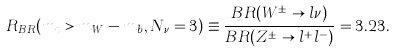<formula> <loc_0><loc_0><loc_500><loc_500>R _ { B R } ( m _ { t } > m _ { W } - m _ { b } , N _ { \nu } = 3 ) \equiv \frac { B R ( W ^ { \pm } \rightarrow l \nu ) } { B R ( Z ^ { \pm } \rightarrow l ^ { + } l ^ { - } ) } = 3 . 2 3 .</formula> 